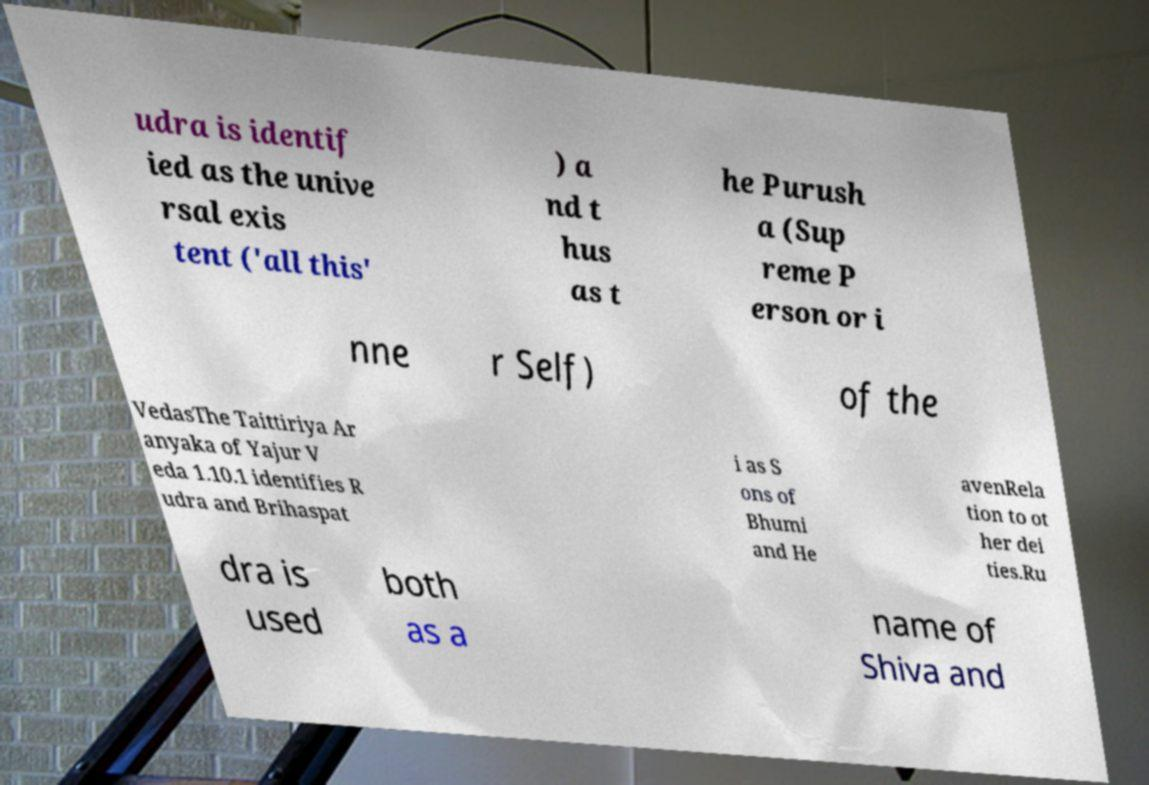Can you accurately transcribe the text from the provided image for me? udra is identif ied as the unive rsal exis tent ('all this' ) a nd t hus as t he Purush a (Sup reme P erson or i nne r Self) of the VedasThe Taittiriya Ar anyaka of Yajur V eda 1.10.1 identifies R udra and Brihaspat i as S ons of Bhumi and He avenRela tion to ot her dei ties.Ru dra is used both as a name of Shiva and 